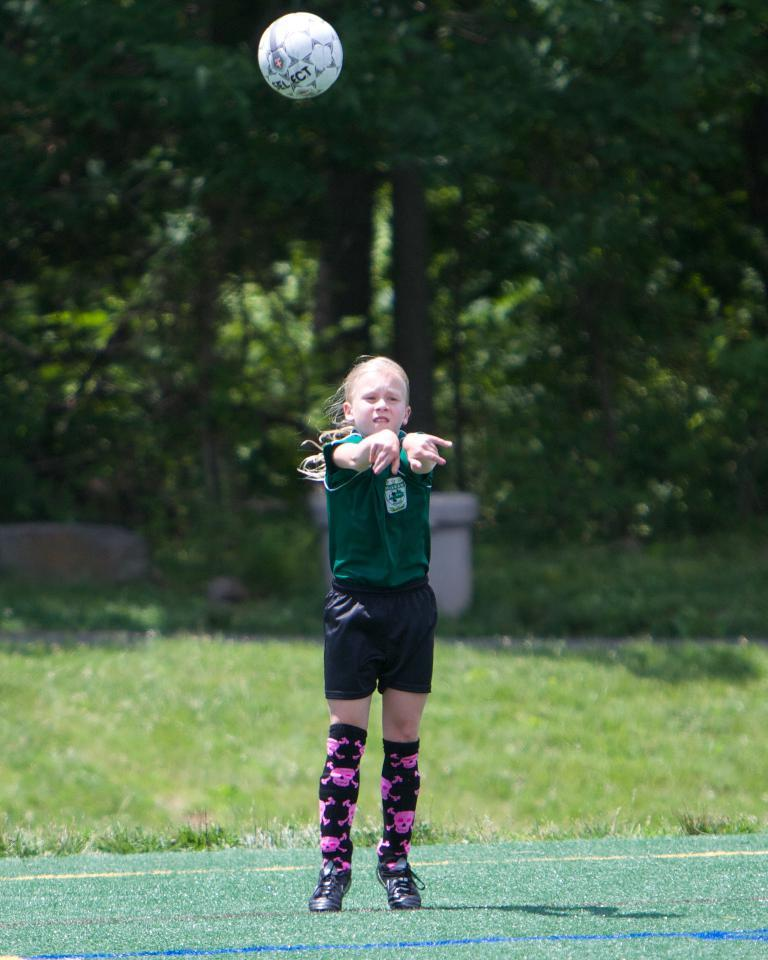What is the person in the image wearing? The person is wearing a green t-shirt and black shorts. What type of environment is visible in the image? There is grass visible in the image, and trees are at the back of the image. What object can be seen at the top of the image? There is a white ball at the top of the image. Where is the throne located in the image? There is no throne present in the image. What type of servant is attending to the person in the image? There is no servant present in the image. 